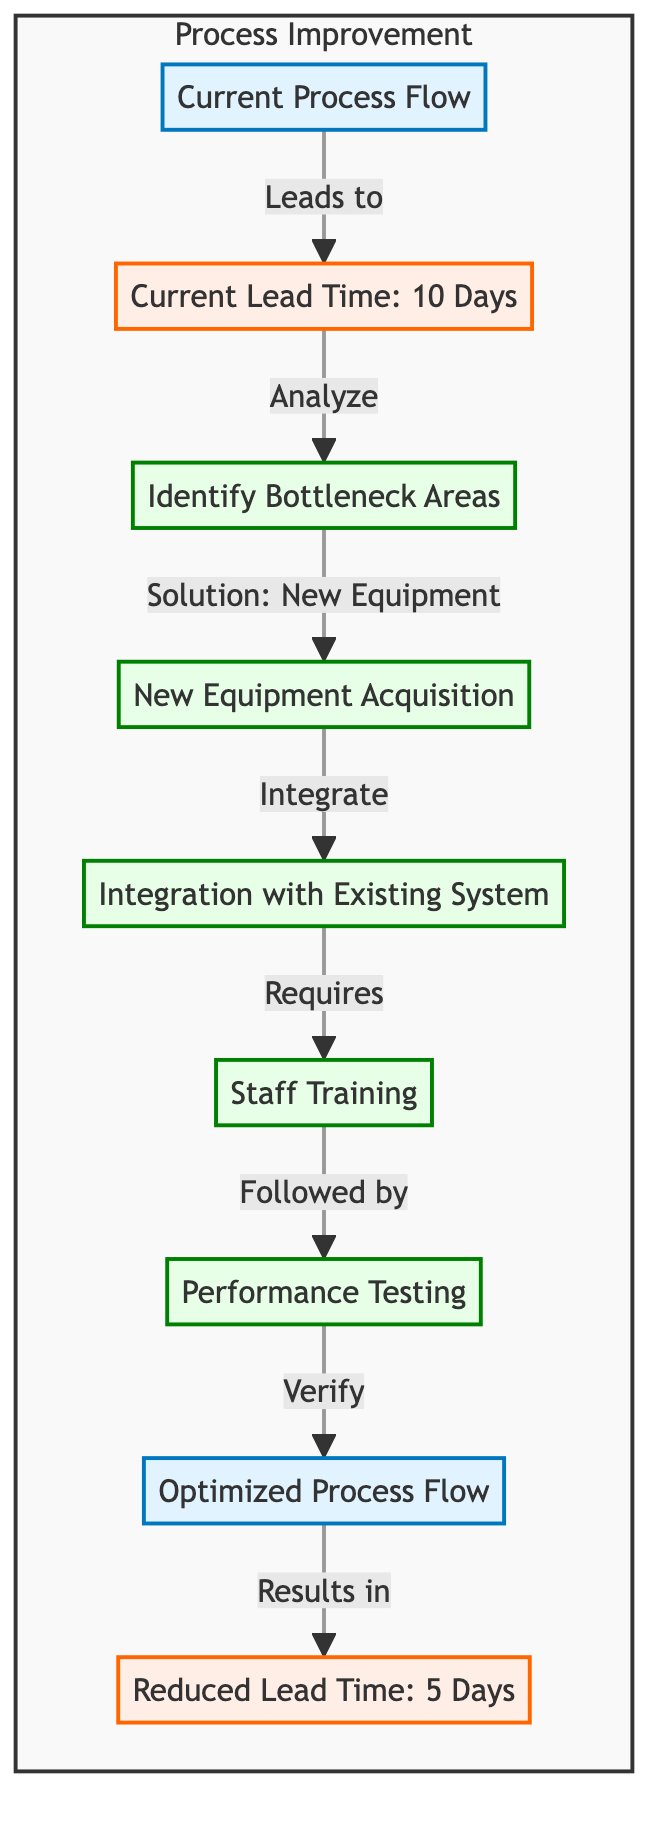What is the current lead time represented in the diagram? The diagram indicates that the current lead time is 10 days, as shown in the respective node labeled "Current Lead Time: 10 Days."
Answer: 10 Days What leads to the identification of bottleneck areas? The flow shows that the "Current Process Flow" leads to the "Current Lead Time," which is then analyzed to identify bottleneck areas. Therefore, the "Current Lead Time" is the node that leads to identifying the bottlenecks.
Answer: Current Lead Time How many action steps are outlined in the diagram? The action steps include identifying bottlenecks, acquiring new equipment, integrating with the existing system, training staff, and testing performance. Counting these together gives a total of five action steps.
Answer: 5 What is the reduced lead time after implementing new equipment? The diagram indicates that after following the entire process, the lead time is reduced to 5 days, as seen in the node labeled "Reduced Lead Time: 5 Days."
Answer: 5 Days What are the components of the process improvement subgraph? The subgraph labeled "Process Improvement" encompasses all components listed in the diagram, which are the existing process, current lead time, identifying bottleneck, new equipment, integration, training, testing, optimized process, and reduced lead time. Thus, the components can be collectively identified.
Answer: 8 Components Which node follows the integration of new equipment? The diagram shows that after the node "Integration with Existing System," the subsequent action is "Staff Training," indicating that training directly follows integration.
Answer: Staff Training What verifies the optimized process flow in the diagram? The flow shows a direct link from "Performance Testing" to the "Optimized Process Flow," indicating that the optimized process is verified by the performance testing conducted beforehand.
Answer: Performance Testing What is the immediate effect of acquiring new equipment? Acquiring new equipment leads directly to the integration with the existing system, indicating that the immediate effect is the integration phase following equipment acquisition.
Answer: Integration with Existing System 